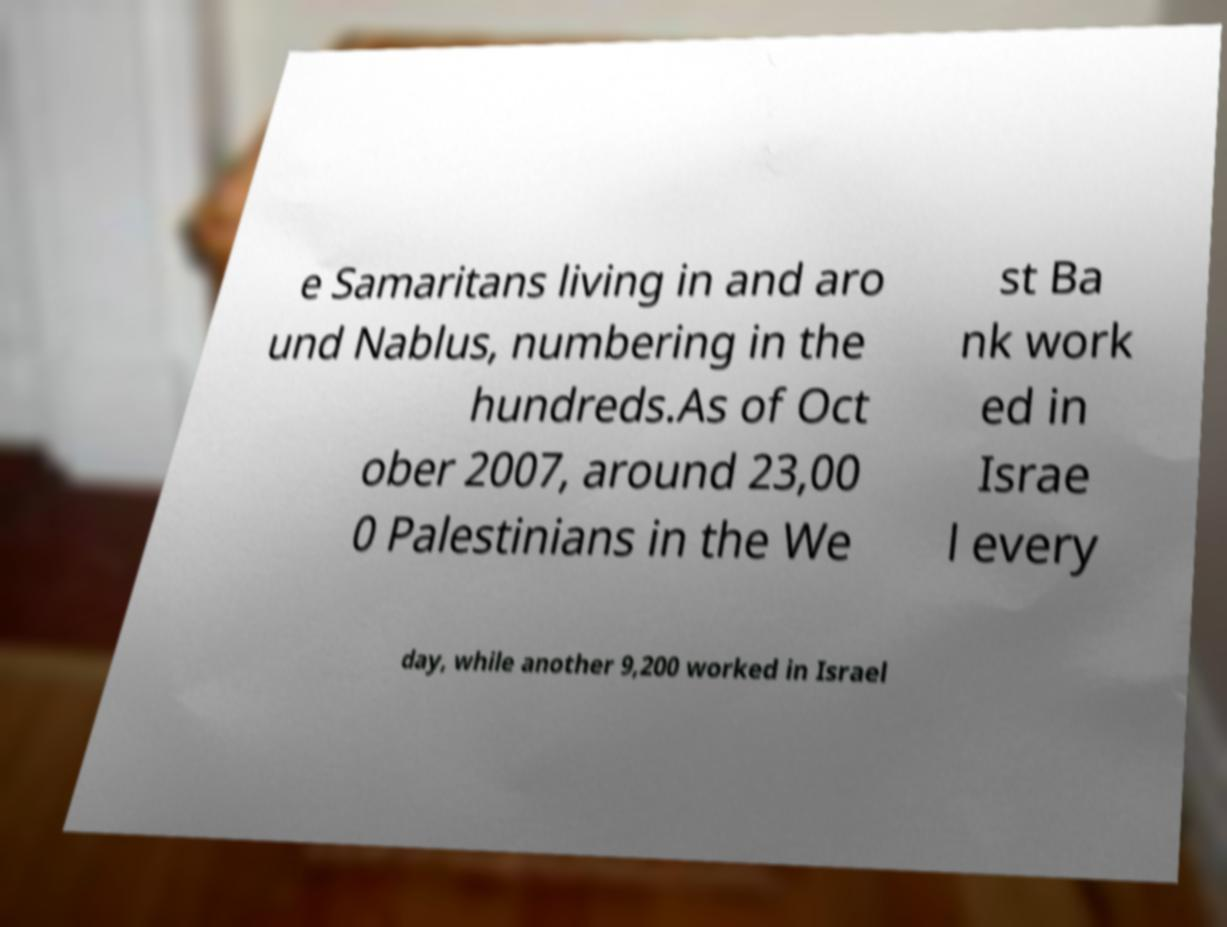Could you extract and type out the text from this image? e Samaritans living in and aro und Nablus, numbering in the hundreds.As of Oct ober 2007, around 23,00 0 Palestinians in the We st Ba nk work ed in Israe l every day, while another 9,200 worked in Israel 